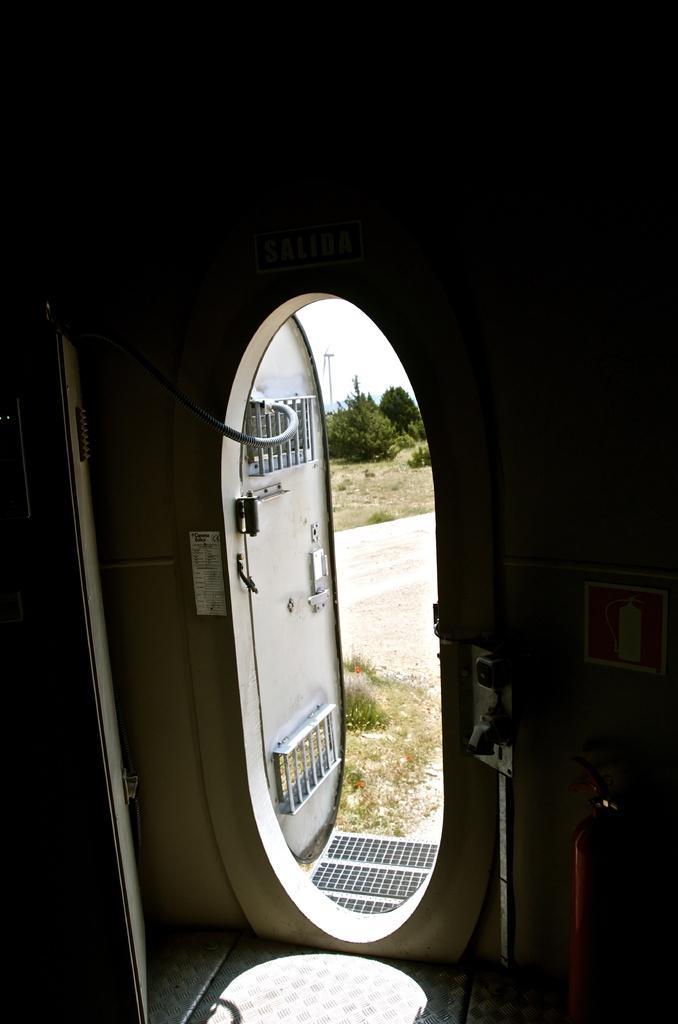Can you describe this image briefly? In this image we can see inside view of a room. In the center of the room we can see a door with cable. To the right side of the image we can see a fire extinguisher placed on the ground, a pole and a signboard on the wall. In the background, we can see a group of trees and the sky. 